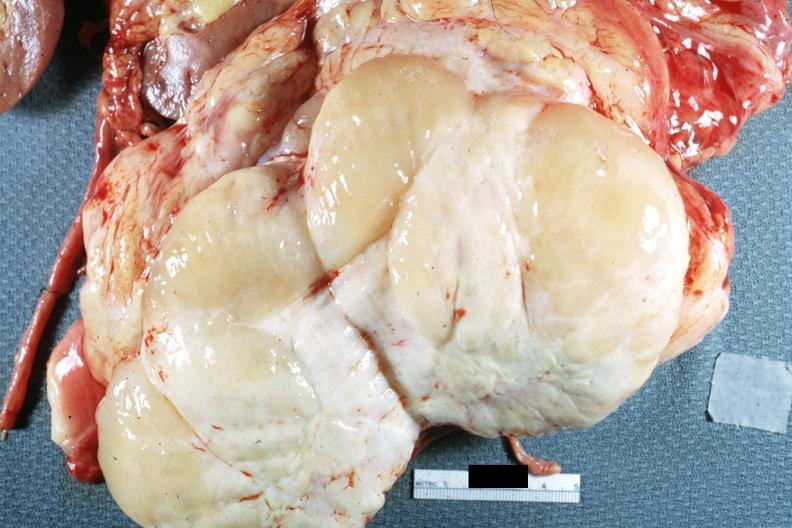what is present?
Answer the question using a single word or phrase. Abdomen 